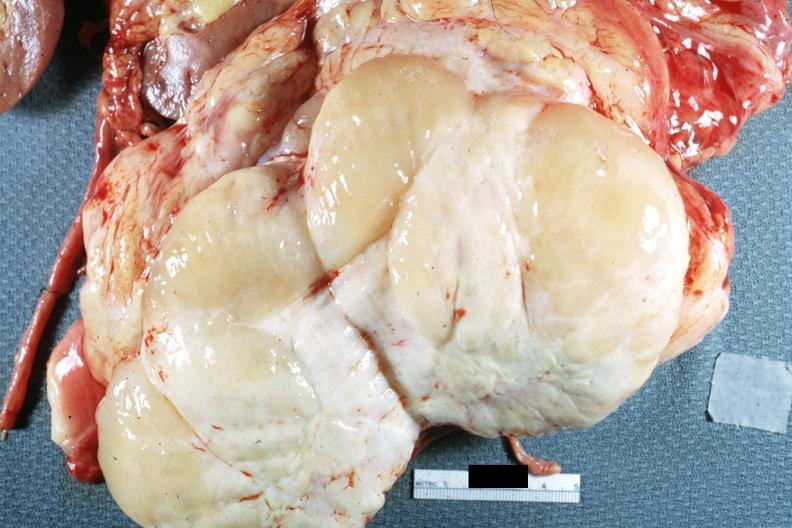what is present?
Answer the question using a single word or phrase. Abdomen 